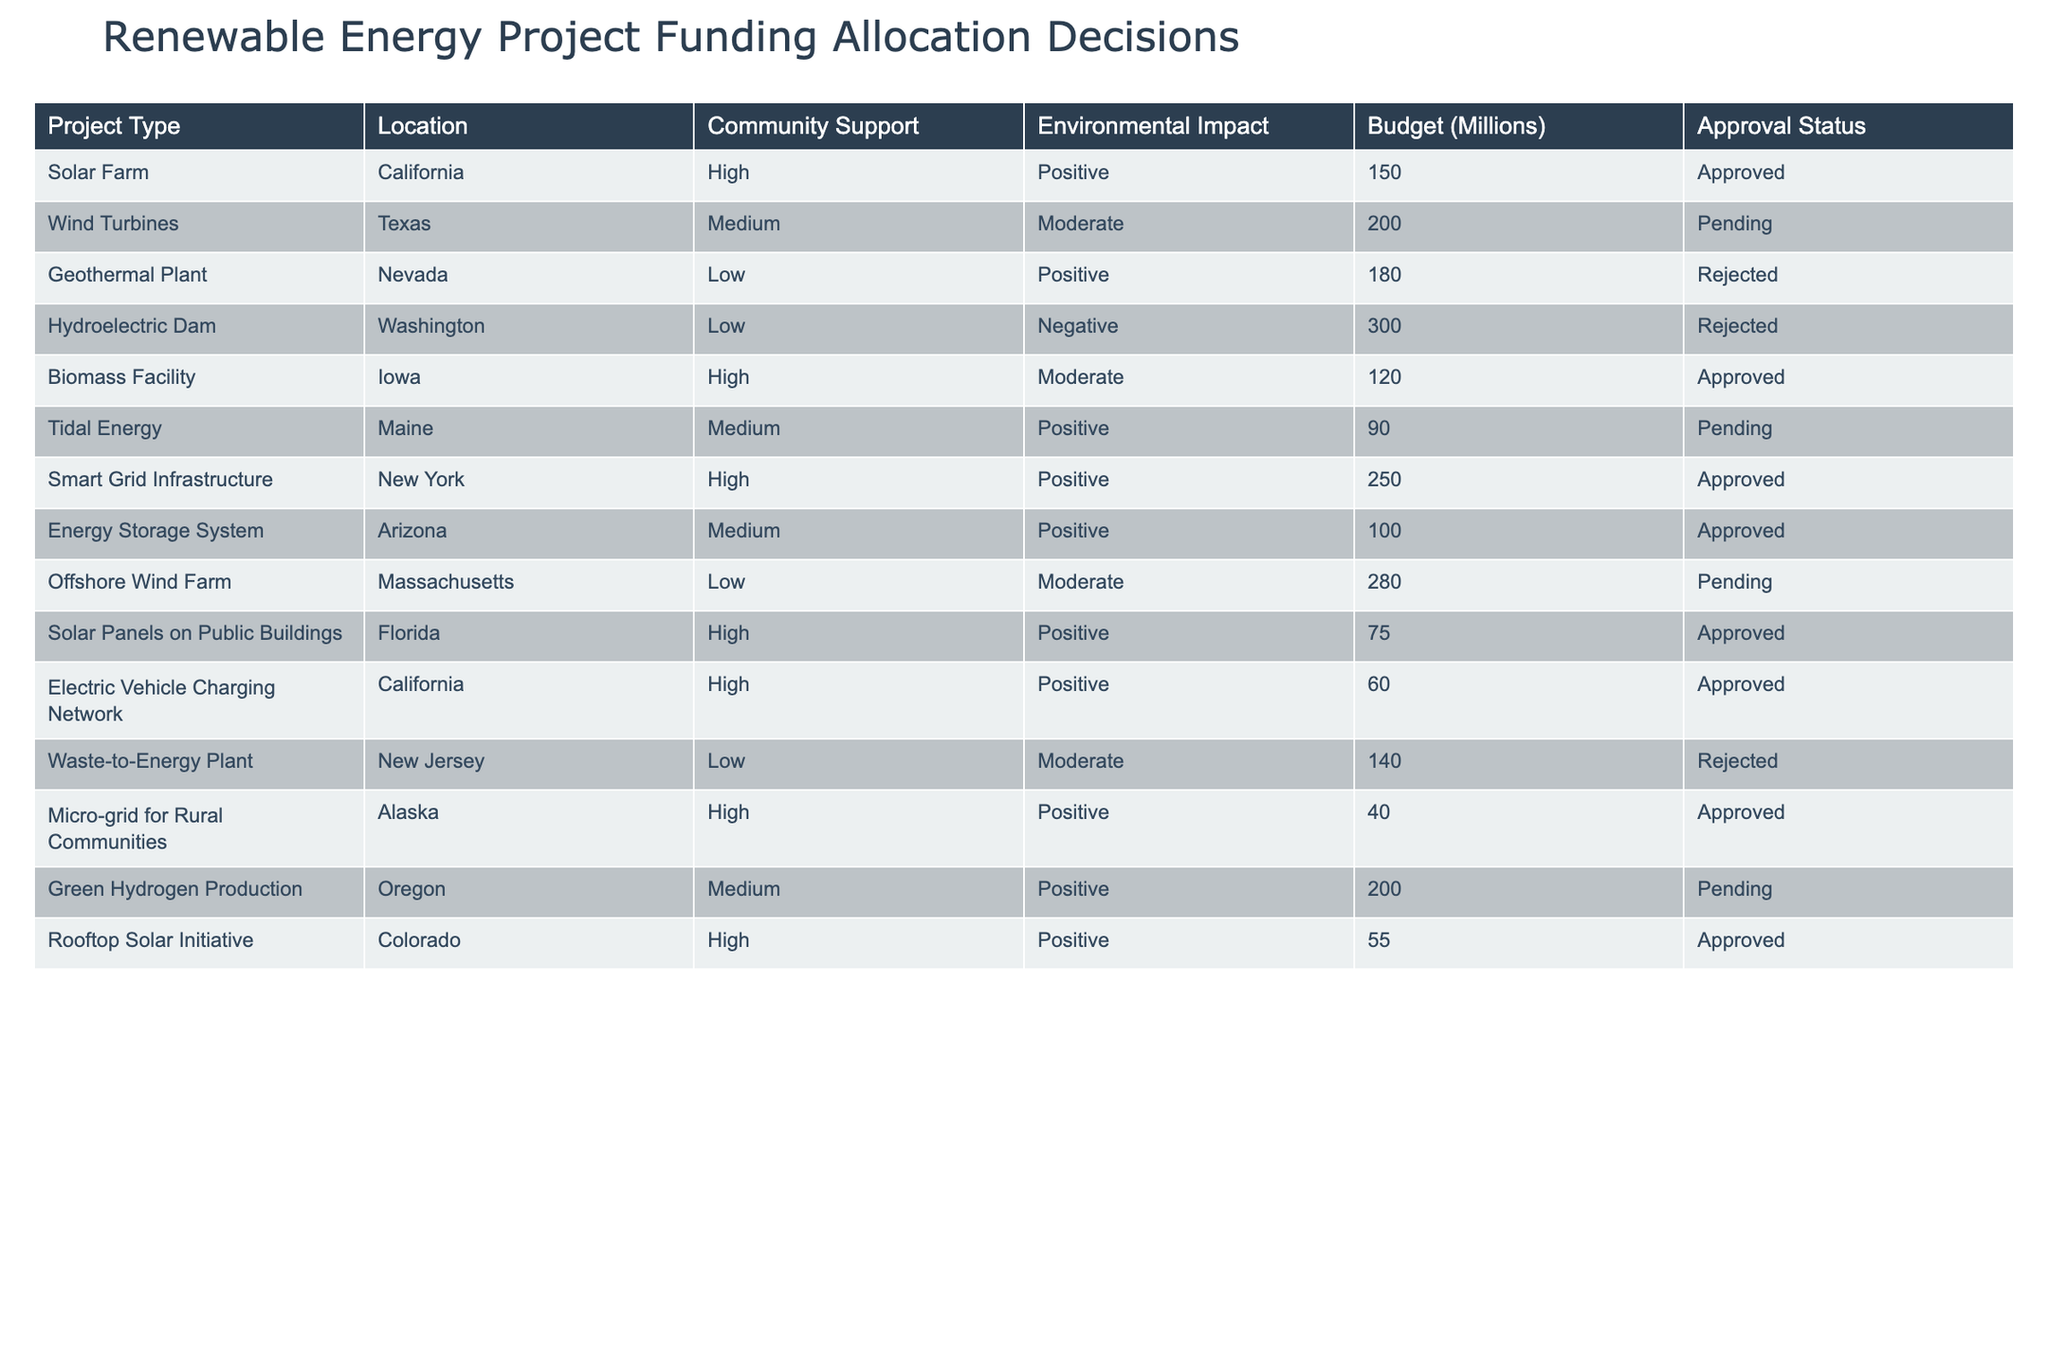What is the approval status of the Offshore Wind Farm project? The Offshore Wind Farm project has an Approval Status of "Pending" as noted in the table under the respective row for this project.
Answer: Pending How many projects have a high level of community support? There are 5 projects with high community support: Solar Farm, Biomass Facility, Smart Grid Infrastructure, Electric Vehicle Charging Network, and Micro-grid for Rural Communities.
Answer: 5 What is the total budget allocated to the projects that are approved? The approved projects and their budgets are: Solar Farm (150), Biomass Facility (120), Smart Grid Infrastructure (250), Energy Storage System (100), Solar Panels on Public Buildings (75), Electric Vehicle Charging Network (60), and Micro-grid for Rural Communities (40). Adding these gives 150 + 120 + 250 + 100 + 75 + 60 + 40 = 795 million.
Answer: 795 million Does the Geothermal Plant have a positive environmental impact? According to the table, the Geothermal Plant has an environmental impact listed as "Positive." However, it also has a rejection status, indicating it may not result in funding.
Answer: No Which project type has the highest budget, and what is its status? The Hydroelectric Dam has the highest budget of 300 million and its approval status is "Rejected."
Answer: Hydroelectric Dam, Rejected What percentage of projects have a negative environmental impact? There are 2 projects with a negative environmental impact: Hydroelectric Dam and another one (Waste-to-Energy Plant). With a total of 12 projects, the percentage is (2/12) * 100 = 16.67%.
Answer: 16.67% Are there any projects in Oregon, and what is their approval status? Yes, there is a project in Oregon: Green Hydrogen Production. Its approval status is "Pending."
Answer: Yes, Pending What is the average budget of the projects that were rejected? The rejected projects are: Geothermal Plant (180), Hydroelectric Dam (300), and Waste-to-Energy Plant (140). The total budget for these projects is 180 + 300 + 140 = 620 million. The average budget is 620 / 3 = 206.67 million.
Answer: 206.67 million 